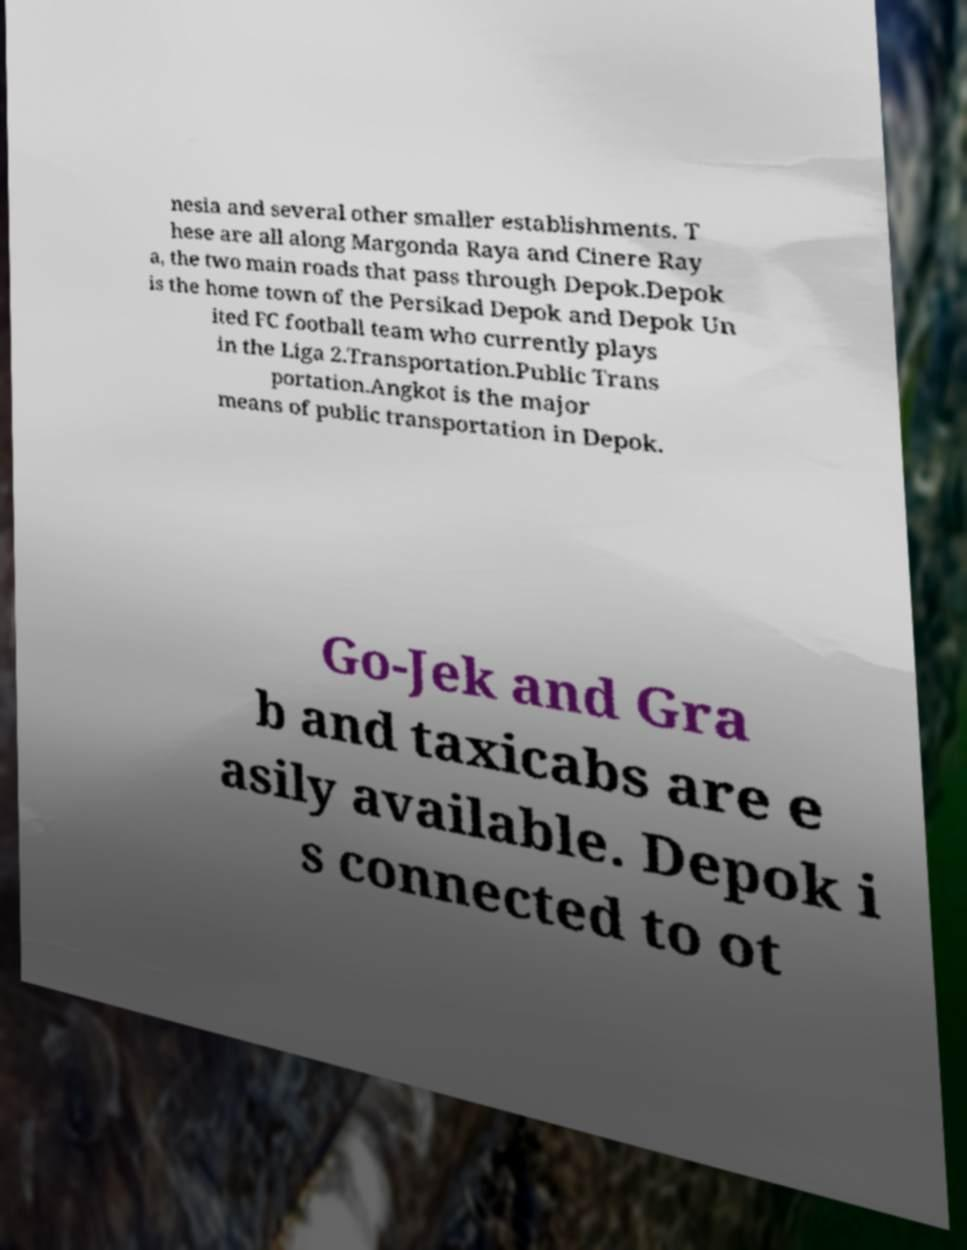For documentation purposes, I need the text within this image transcribed. Could you provide that? nesia and several other smaller establishments. T hese are all along Margonda Raya and Cinere Ray a, the two main roads that pass through Depok.Depok is the home town of the Persikad Depok and Depok Un ited FC football team who currently plays in the Liga 2.Transportation.Public Trans portation.Angkot is the major means of public transportation in Depok. Go-Jek and Gra b and taxicabs are e asily available. Depok i s connected to ot 